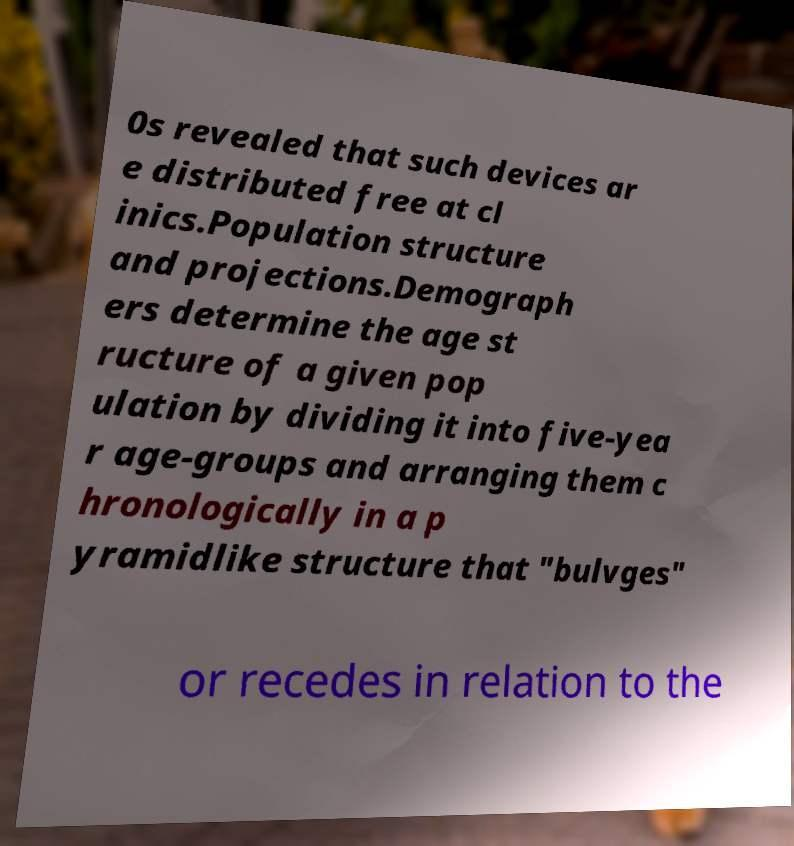I need the written content from this picture converted into text. Can you do that? 0s revealed that such devices ar e distributed free at cl inics.Population structure and projections.Demograph ers determine the age st ructure of a given pop ulation by dividing it into five-yea r age-groups and arranging them c hronologically in a p yramidlike structure that "bulvges" or recedes in relation to the 